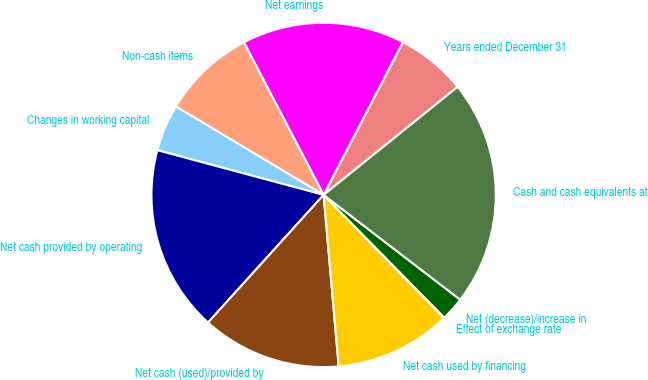Convert chart to OTSL. <chart><loc_0><loc_0><loc_500><loc_500><pie_chart><fcel>Years ended December 31<fcel>Net earnings<fcel>Non-cash items<fcel>Changes in working capital<fcel>Net cash provided by operating<fcel>Net cash (used)/provided by<fcel>Net cash used by financing<fcel>Effect of exchange rate<fcel>Net (decrease)/increase in<fcel>Cash and cash equivalents at<nl><fcel>6.58%<fcel>15.29%<fcel>8.75%<fcel>4.4%<fcel>17.47%<fcel>13.11%<fcel>10.93%<fcel>0.04%<fcel>2.22%<fcel>21.21%<nl></chart> 